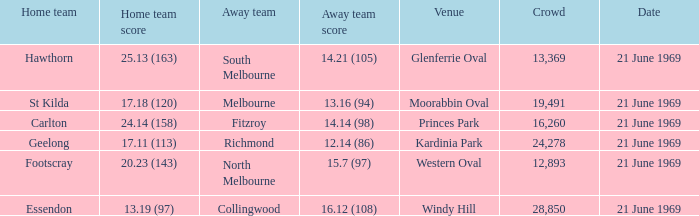What is Essendon's home team that has an away crowd size larger than 19,491? Collingwood. 